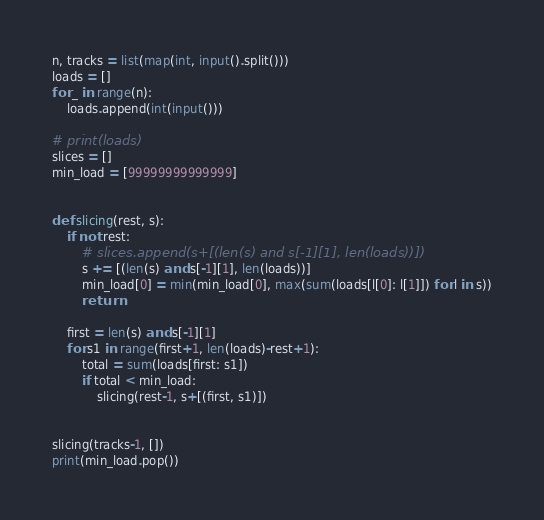Convert code to text. <code><loc_0><loc_0><loc_500><loc_500><_Python_>n, tracks = list(map(int, input().split()))
loads = []
for _ in range(n):
    loads.append(int(input()))

# print(loads)
slices = []
min_load = [99999999999999]


def slicing(rest, s):
    if not rest:
        # slices.append(s+[(len(s) and s[-1][1], len(loads))])
        s += [(len(s) and s[-1][1], len(loads))]
        min_load[0] = min(min_load[0], max(sum(loads[l[0]: l[1]]) for l in s))
        return

    first = len(s) and s[-1][1]
    for s1 in range(first+1, len(loads)-rest+1):
        total = sum(loads[first: s1])
        if total < min_load:
            slicing(rest-1, s+[(first, s1)])


slicing(tracks-1, [])
print(min_load.pop())
</code> 